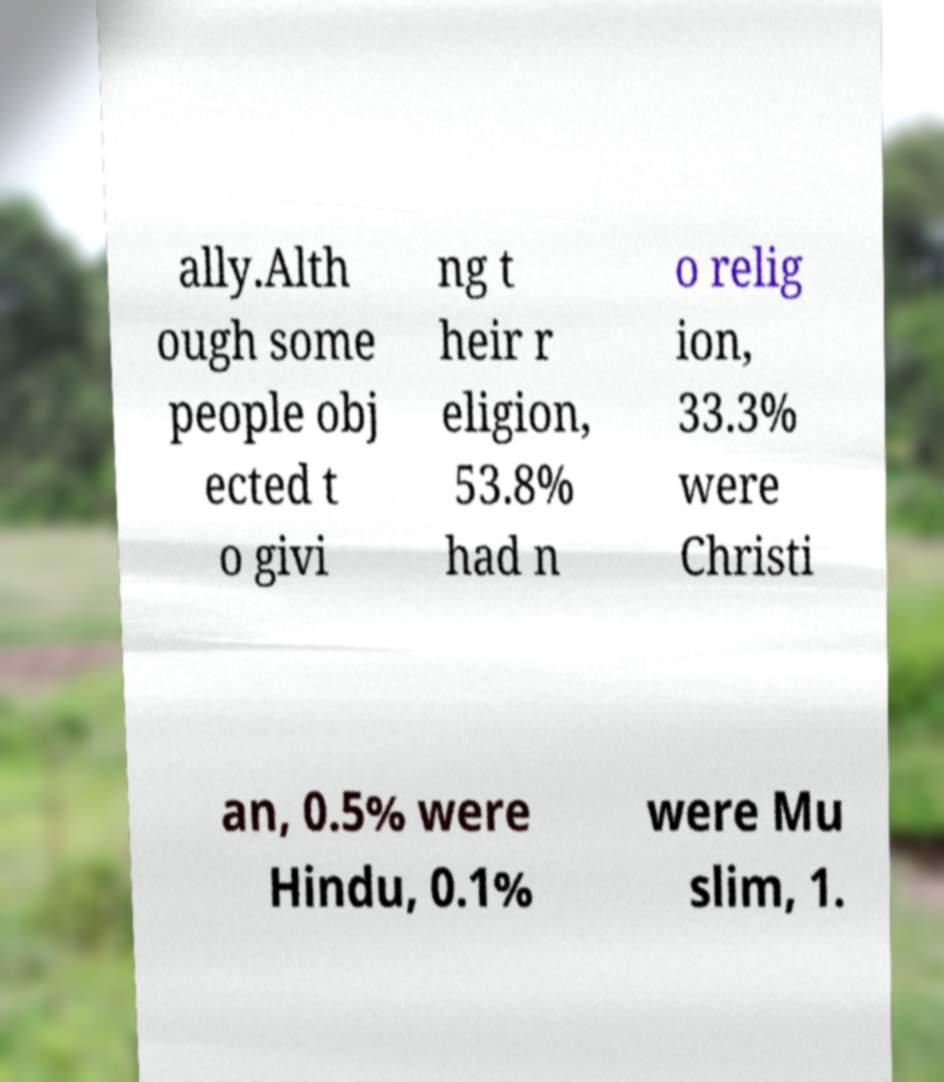There's text embedded in this image that I need extracted. Can you transcribe it verbatim? ally.Alth ough some people obj ected t o givi ng t heir r eligion, 53.8% had n o relig ion, 33.3% were Christi an, 0.5% were Hindu, 0.1% were Mu slim, 1. 